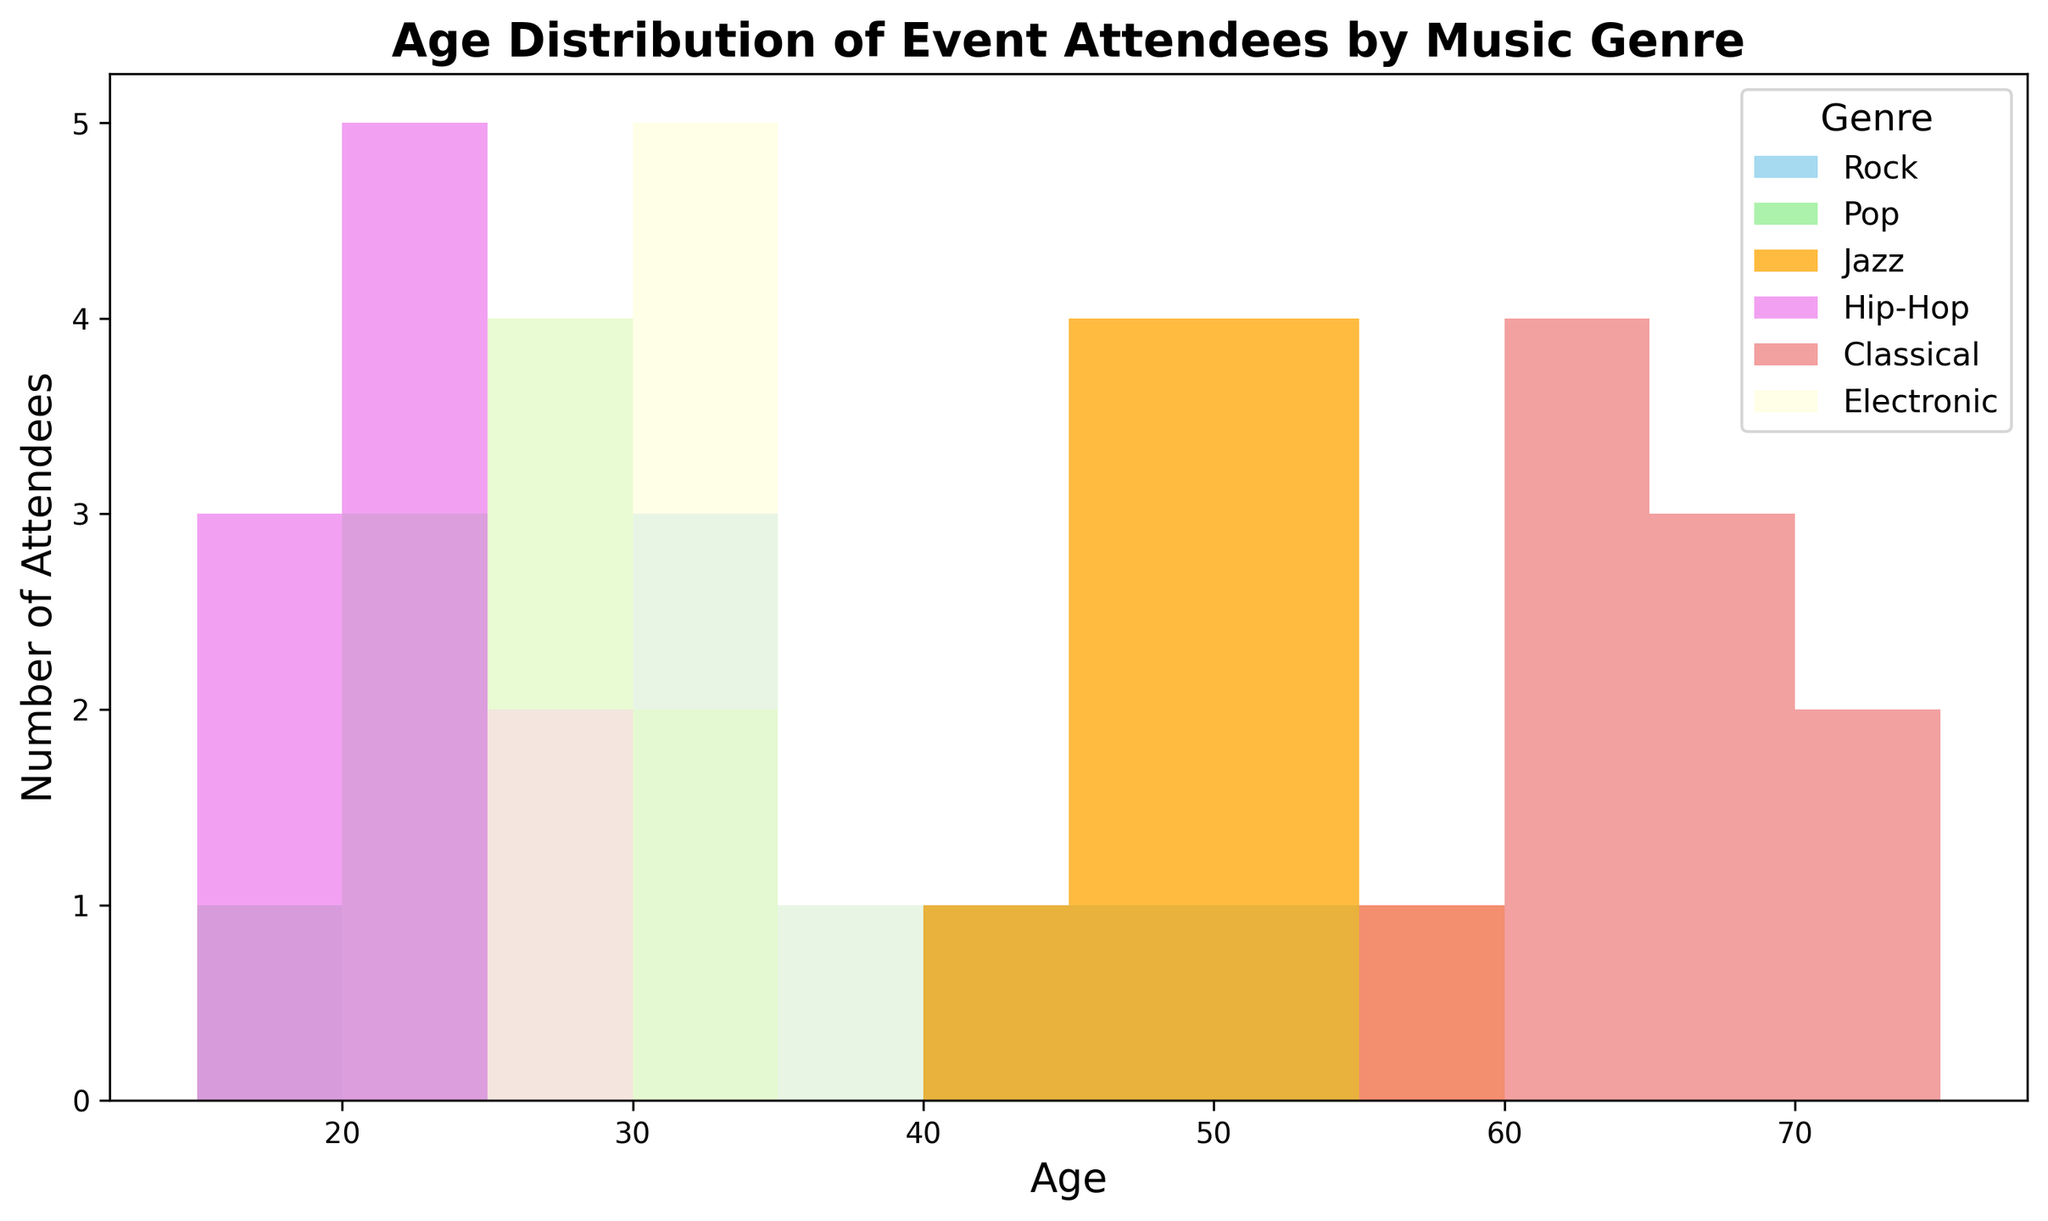What music genre attracts the oldest age group? Observing the age ranges from the histogram, the Classical genre has the oldest age range, with most attendees being between 59 and 72 years old.
Answer: Classical Which genre has the most diverse age range of attendees? From the visual bars in the histogram, Rock shows attendees across a wide range of ages, from 19 to 50, indicating it has the most diverse age range.
Answer: Rock How does the age distribution of Pop compare to Hip-Hop? Both genres attract younger audiences, but Pop has attendees mostly between 18 and 33 years, while Hip-Hop has attendees mostly between 17 and 27 years, indicating slight overlaps but generally younger audiences in Hip-Hop.
Answer: Pop attendees' ages range from 18 to 33 and Hip-Hop attendees range from 17 to 27 Which age group is more prominent in Jazz compared to Electronic? Jazz is prominent in the 40 to 55 age group, while Electronic has more attendees mostly in the 26 to 35 age group. Thus, Jazz attracts an older demographic in comparison.
Answer: 40 to 55 for Jazz Are there genres that do not overlap in age distribution at all? By examining the bar overlaps, Classical and Electronic have no overlapping age ranges. Classical ranges from 59 to 72, while Electronic ranges from 26 to 35.
Answer: Yes, Classical and Electronic What is the age range of attendees for the Rock genre? The histogram shows that Rock genre attendees' ages range from 19 to 50 years old.
Answer: 19 to 50 years old How many genres have a peak in the 20-25 age group? Checking the histogram, Rock, Pop and Hip-Hop have noticeable peaks in the 20-25 age range.
Answer: Three genres: Rock, Pop, Hip-Hop Which genre has the smallest age range? The histogram shows that Hip-Hop has the smallest age range, from 17 to 27 years old.
Answer: Hip-Hop What age group is most frequent for the Jazz genre? The histogram for Jazz shows the highest frequency of attendees in the 45-50 age group.
Answer: 45-50 age group 